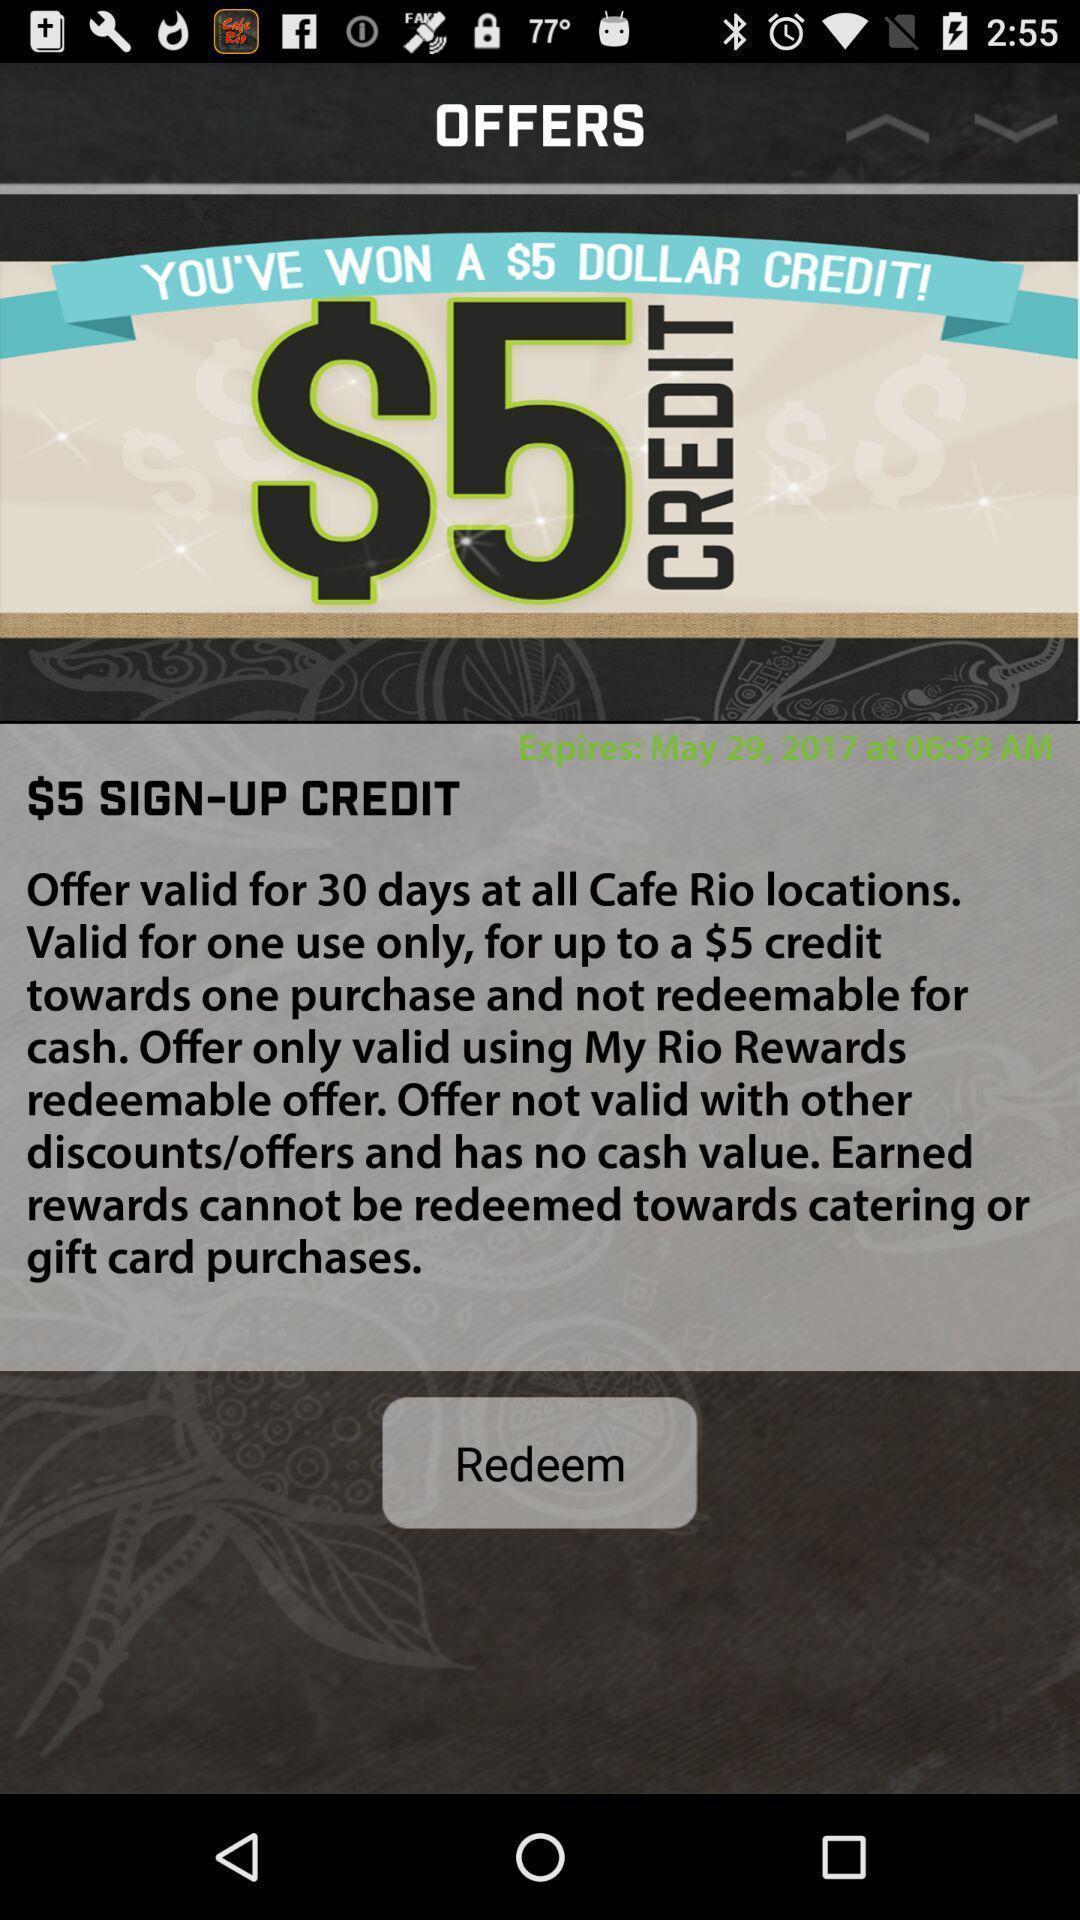Please provide a description for this image. Sign-up page for redeem the credit on financial app. 